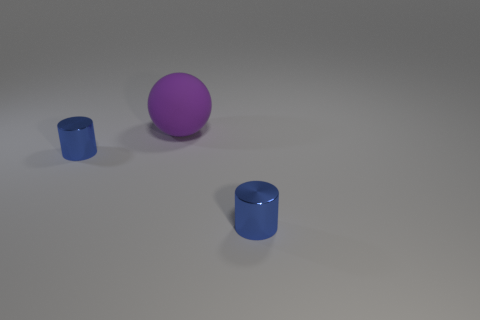Are there any other things that have the same material as the purple thing?
Your answer should be compact. No. What is the small blue cylinder that is left of the purple object made of?
Make the answer very short. Metal. Is the color of the tiny metallic thing that is right of the matte thing the same as the matte thing?
Ensure brevity in your answer.  No. There is a cylinder that is in front of the tiny blue shiny object to the left of the big sphere; how big is it?
Keep it short and to the point. Small. Are there more large matte spheres behind the purple ball than purple balls?
Provide a succinct answer. No. There is a shiny object that is to the left of the purple matte ball; is its size the same as the sphere?
Offer a very short reply. No. Are there any other rubber balls of the same color as the sphere?
Give a very brief answer. No. Is the number of small cylinders right of the big purple object the same as the number of blue objects?
Your response must be concise. No. How many blue cylinders have the same material as the sphere?
Your answer should be very brief. 0. There is a large purple matte object; is its shape the same as the tiny object that is to the left of the big object?
Make the answer very short. No. 